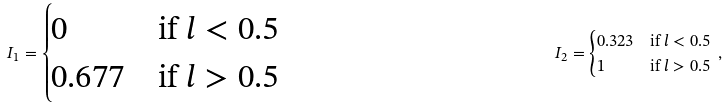Convert formula to latex. <formula><loc_0><loc_0><loc_500><loc_500>I _ { 1 } = \begin{cases} 0 & \text {if } l < 0 . 5 \\ 0 . 6 7 7 & \text {if } l > 0 . 5 \end{cases} & & I _ { 2 } = \begin{cases} 0 . 3 2 3 & \text {if } l < 0 . 5 \\ 1 & \text {if } l > 0 . 5 \end{cases} \, ,</formula> 